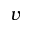<formula> <loc_0><loc_0><loc_500><loc_500>v</formula> 